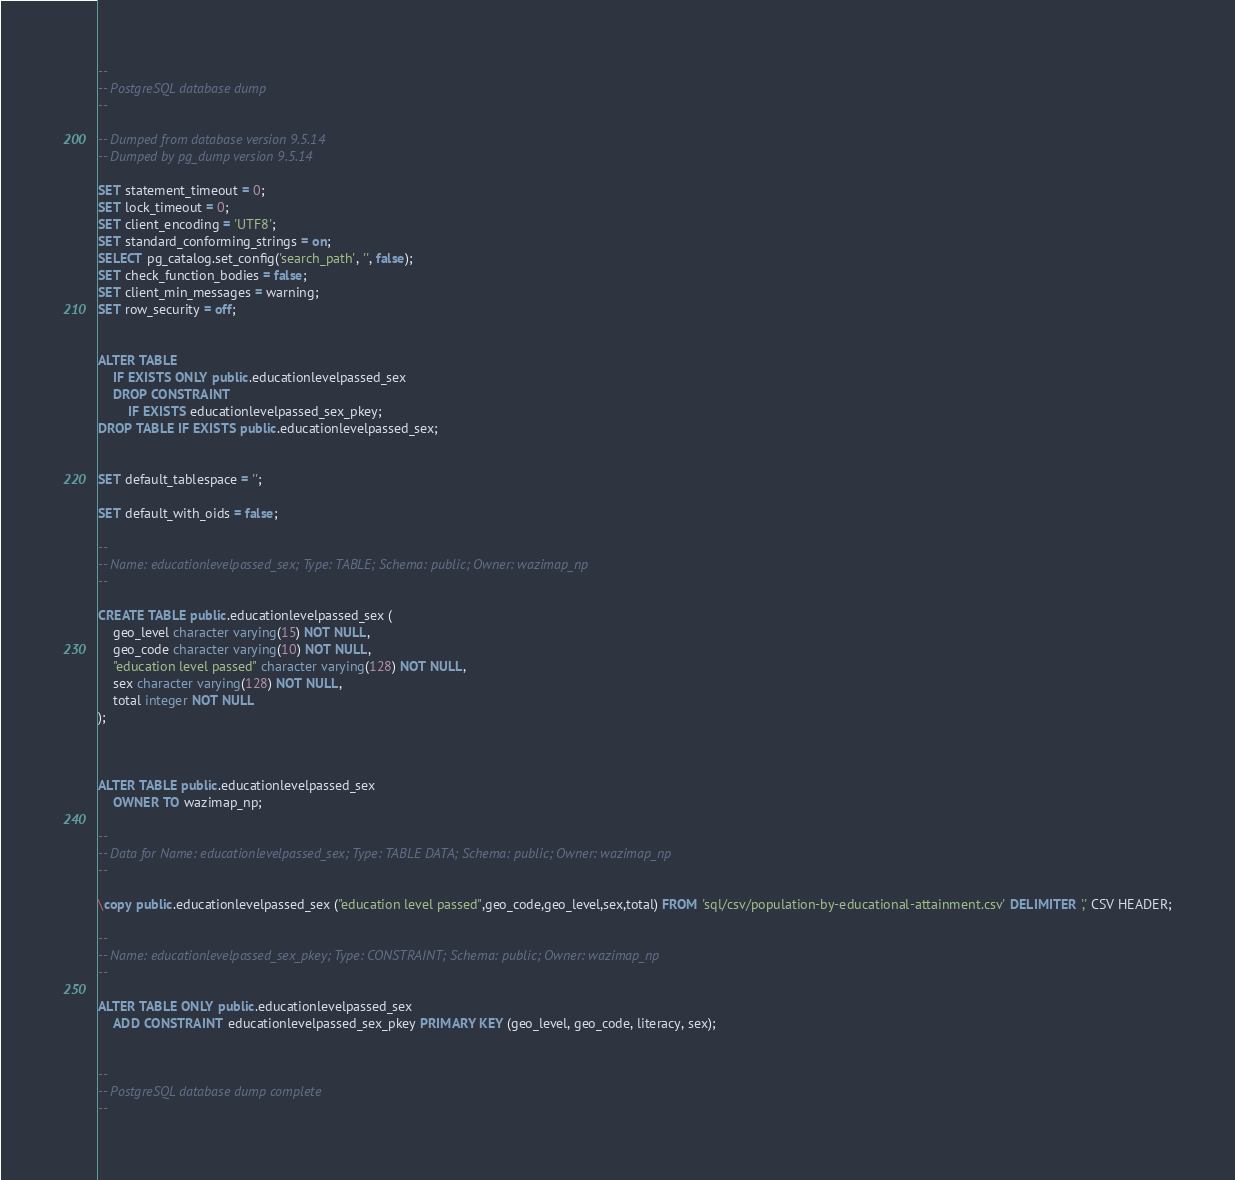<code> <loc_0><loc_0><loc_500><loc_500><_SQL_>--
-- PostgreSQL database dump
--

-- Dumped from database version 9.5.14
-- Dumped by pg_dump version 9.5.14

SET statement_timeout = 0;
SET lock_timeout = 0;
SET client_encoding = 'UTF8';
SET standard_conforming_strings = on;
SELECT pg_catalog.set_config('search_path', '', false);
SET check_function_bodies = false;
SET client_min_messages = warning;
SET row_security = off;


ALTER TABLE
    IF EXISTS ONLY public.educationlevelpassed_sex
    DROP CONSTRAINT
        IF EXISTS educationlevelpassed_sex_pkey;
DROP TABLE IF EXISTS public.educationlevelpassed_sex;


SET default_tablespace = '';

SET default_with_oids = false;

--
-- Name: educationlevelpassed_sex; Type: TABLE; Schema: public; Owner: wazimap_np
--

CREATE TABLE public.educationlevelpassed_sex (
    geo_level character varying(15) NOT NULL,
    geo_code character varying(10) NOT NULL,
    "education level passed" character varying(128) NOT NULL,
    sex character varying(128) NOT NULL,
    total integer NOT NULL
);



ALTER TABLE public.educationlevelpassed_sex
    OWNER TO wazimap_np;

--
-- Data for Name: educationlevelpassed_sex; Type: TABLE DATA; Schema: public; Owner: wazimap_np
--

\copy public.educationlevelpassed_sex ("education level passed",geo_code,geo_level,sex,total) FROM 'sql/csv/population-by-educational-attainment.csv' DELIMITER ',' CSV HEADER;

--
-- Name: educationlevelpassed_sex_pkey; Type: CONSTRAINT; Schema: public; Owner: wazimap_np
--

ALTER TABLE ONLY public.educationlevelpassed_sex
    ADD CONSTRAINT educationlevelpassed_sex_pkey PRIMARY KEY (geo_level, geo_code, literacy, sex);


--
-- PostgreSQL database dump complete
--
</code> 